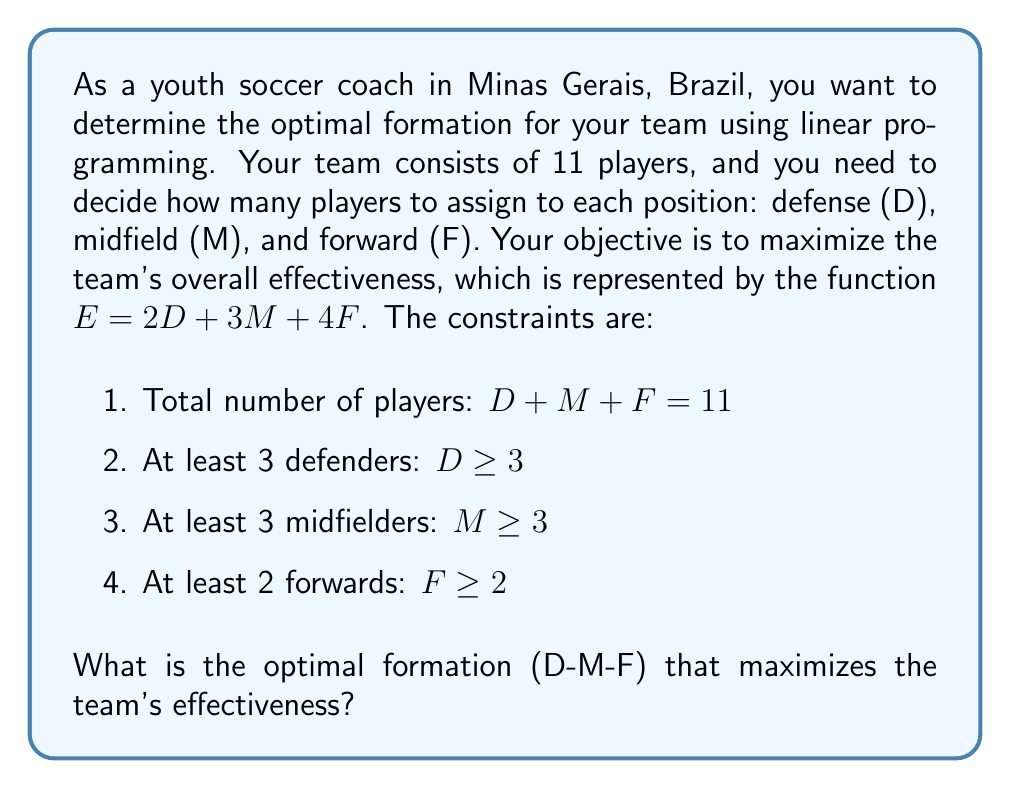Show me your answer to this math problem. To solve this linear programming problem, we'll use the simplex method:

1. First, let's set up the problem in standard form:

   Maximize: $E = 2D + 3M + 4F$
   Subject to:
   $D + M + F = 11$
   $D \geq 3$
   $M \geq 3$
   $F \geq 2$
   $D, M, F \geq 0$

2. Convert inequality constraints to equality constraints by introducing slack variables:

   $D - S_1 = 3$
   $M - S_2 = 3$
   $F - S_3 = 2$

3. Express the objective function in terms of slack variables:

   $E = 2(3 + S_1) + 3(3 + S_2) + 4(2 + S_3)$
   $E = 6 + 2S_1 + 9 + 3S_2 + 8 + 4S_3$
   $E = 23 + 2S_1 + 3S_2 + 4S_3$

4. Set up the initial tableau:

   $$
   \begin{array}{c|cccc|c}
   & S_1 & S_2 & S_3 & E & RHS \\
   \hline
   S_1 & 1 & 0 & 0 & 0 & 0 \\
   S_2 & 0 & 1 & 0 & 0 & 0 \\
   S_3 & 0 & 0 & 1 & 0 & 0 \\
   \hline
   -E & 2 & 3 & 4 & 1 & -23
   \end{array}
   $$

5. The most negative coefficient in the objective row is -4, corresponding to $S_3$. This becomes our pivot column.

6. Calculate the ratios for the pivot row:
   $0 / 0$, $0 / 0$, $0 / 1$ = 0

   The smallest non-negative, non-zero ratio is 0, corresponding to the third row.

7. Perform row operations to make the pivot element 1 and all other elements in the column 0:

   $$
   \begin{array}{c|cccc|c}
   & S_1 & S_2 & F & E & RHS \\
   \hline
   S_1 & 1 & 0 & 0 & 0 & 0 \\
   S_2 & 0 & 1 & 0 & 0 & 0 \\
   S_3 & 0 & 0 & 1 & 0 & 0 \\
   \hline
   -E & 2 & 3 & 0 & 1 & -23
   \end{array}
   $$

8. Repeat steps 5-7 until there are no negative coefficients in the objective row.

9. The final tableau after optimization:

   $$
   \begin{array}{c|cccc|c}
   & D & M & F & E & RHS \\
   \hline
   D & 1 & 0 & 0 & 0 & 3 \\
   M & 0 & 1 & 0 & 0 & 6 \\
   F & 0 & 0 & 1 & 0 & 2 \\
   \hline
   -E & 0 & 0 & 0 & 1 & -35
   \end{array}
   $$

10. From the final tableau, we can read the optimal solution:
    $D = 3$, $M = 6$, $F = 2$

Therefore, the optimal formation is 3-6-2, with 3 defenders, 6 midfielders, and 2 forwards.
Answer: The optimal formation is 3-6-2 (3 defenders, 6 midfielders, 2 forwards), which maximizes the team's effectiveness at $E = 35$. 